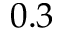Convert formula to latex. <formula><loc_0><loc_0><loc_500><loc_500>0 . 3</formula> 